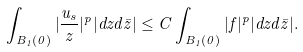<formula> <loc_0><loc_0><loc_500><loc_500>\int _ { B _ { 1 } ( 0 ) } | \frac { u _ { s } } { z } | ^ { p } | d z d \bar { z } | \leq C \int _ { B _ { 1 } ( 0 ) } | f | ^ { p } | d z d \bar { z } | .</formula> 